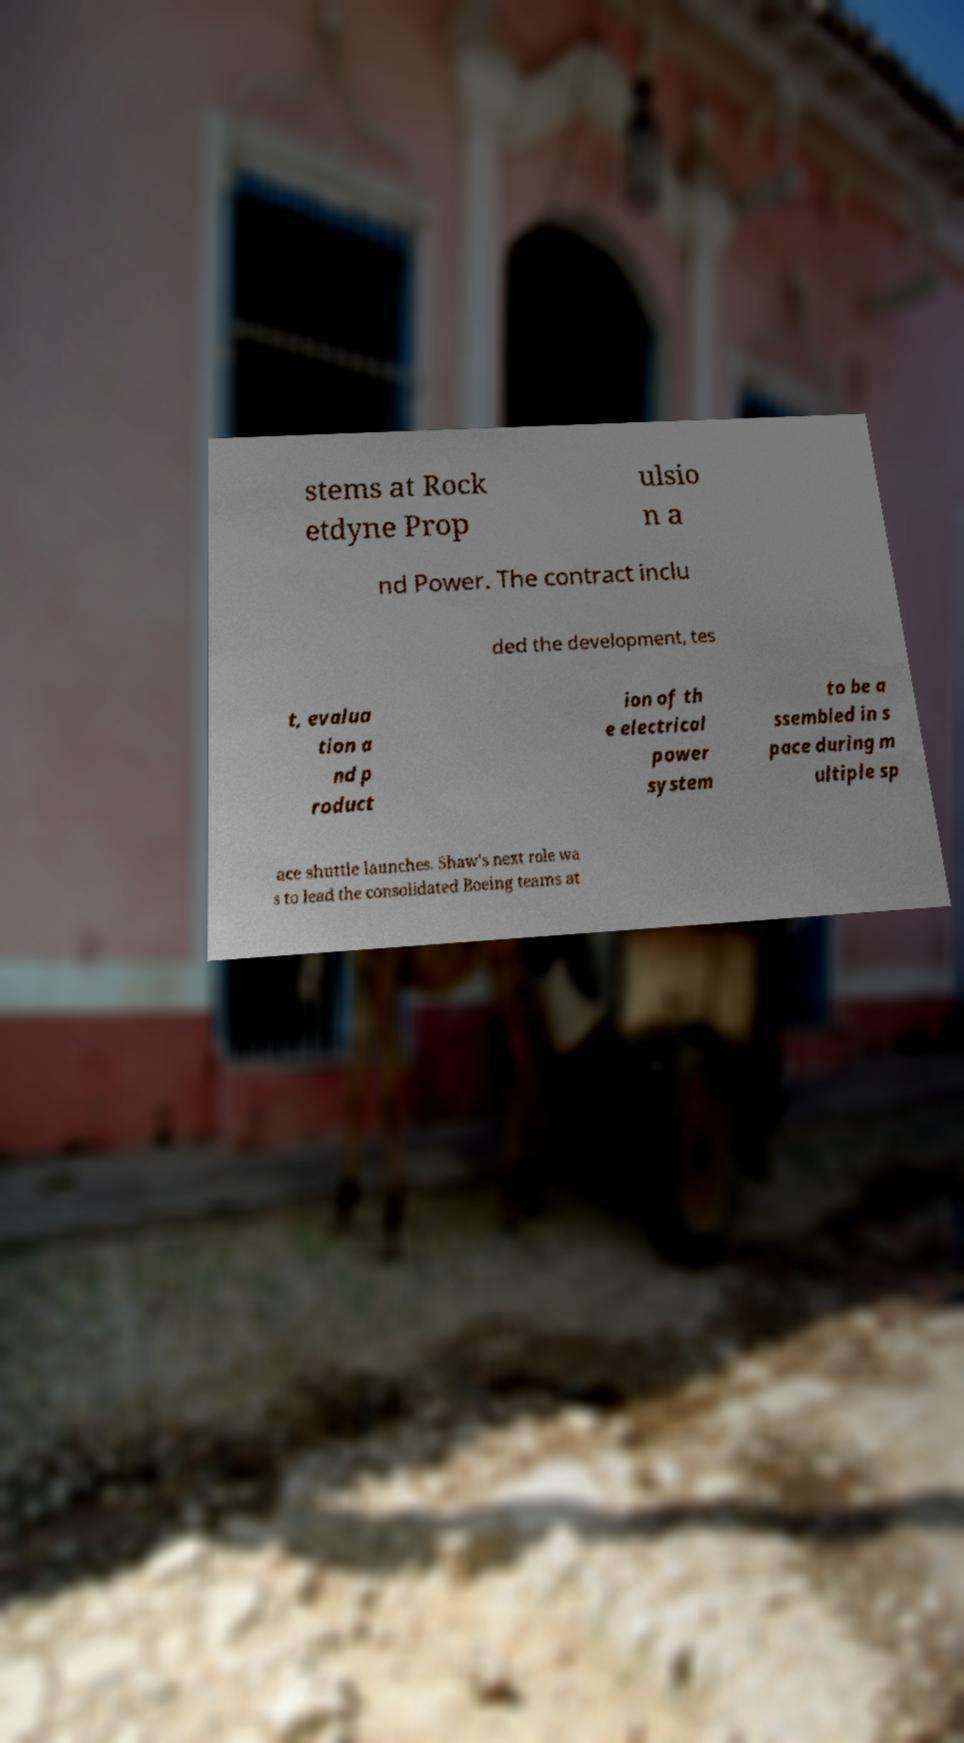What messages or text are displayed in this image? I need them in a readable, typed format. stems at Rock etdyne Prop ulsio n a nd Power. The contract inclu ded the development, tes t, evalua tion a nd p roduct ion of th e electrical power system to be a ssembled in s pace during m ultiple sp ace shuttle launches. Shaw's next role wa s to lead the consolidated Boeing teams at 